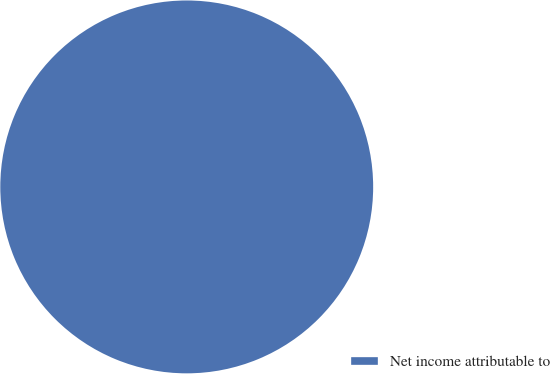Convert chart to OTSL. <chart><loc_0><loc_0><loc_500><loc_500><pie_chart><fcel>Net income attributable to<nl><fcel>100.0%<nl></chart> 